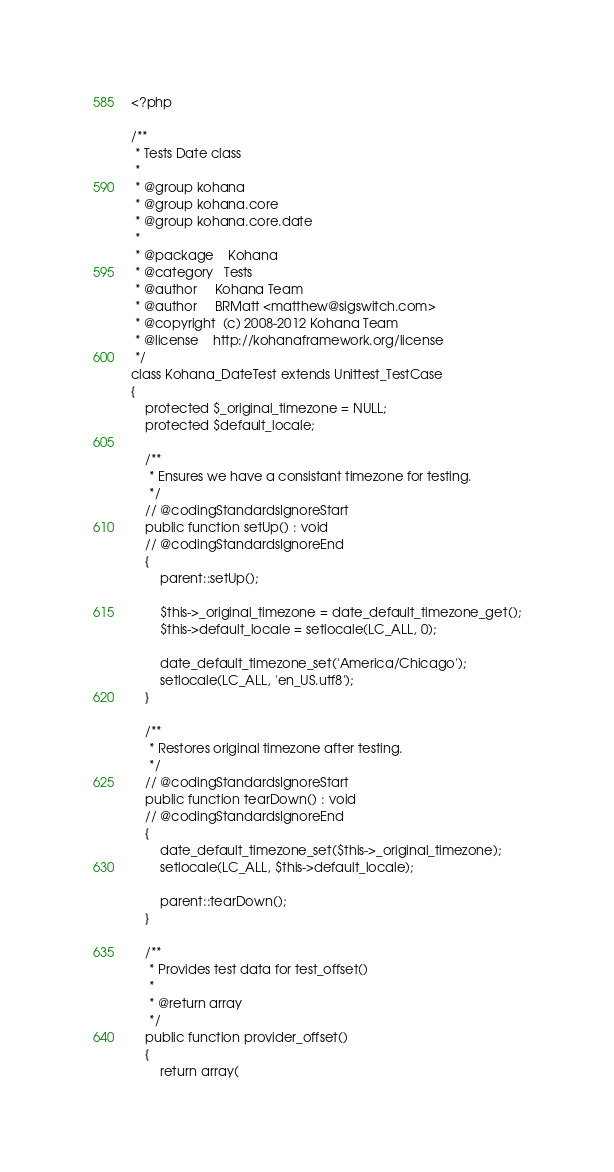<code> <loc_0><loc_0><loc_500><loc_500><_PHP_><?php

/**
 * Tests Date class
 *
 * @group kohana
 * @group kohana.core
 * @group kohana.core.date
 *
 * @package    Kohana
 * @category   Tests
 * @author     Kohana Team
 * @author     BRMatt <matthew@sigswitch.com>
 * @copyright  (c) 2008-2012 Kohana Team
 * @license    http://kohanaframework.org/license
 */
class Kohana_DateTest extends Unittest_TestCase
{
	protected $_original_timezone = NULL;
	protected $default_locale;

	/**
	 * Ensures we have a consistant timezone for testing.
	 */
	// @codingStandardsIgnoreStart
	public function setUp() : void
	// @codingStandardsIgnoreEnd
	{
		parent::setUp();

		$this->_original_timezone = date_default_timezone_get();
		$this->default_locale = setlocale(LC_ALL, 0);

		date_default_timezone_set('America/Chicago');
		setlocale(LC_ALL, 'en_US.utf8');
	}

	/**
	 * Restores original timezone after testing.
	 */
	// @codingStandardsIgnoreStart
	public function tearDown() : void
	// @codingStandardsIgnoreEnd
	{
		date_default_timezone_set($this->_original_timezone);
		setlocale(LC_ALL, $this->default_locale);

		parent::tearDown();
	}

	/**
	 * Provides test data for test_offset()
	 *
	 * @return array
	 */
	public function provider_offset()
	{
		return array(</code> 